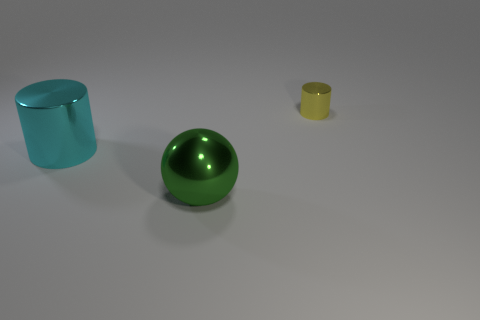Add 3 green metal things. How many objects exist? 6 Subtract all spheres. How many objects are left? 2 Subtract 1 balls. How many balls are left? 0 Subtract all small yellow metal objects. Subtract all tiny purple rubber balls. How many objects are left? 2 Add 3 large metallic cylinders. How many large metallic cylinders are left? 4 Add 2 cyan shiny cylinders. How many cyan shiny cylinders exist? 3 Subtract 0 blue blocks. How many objects are left? 3 Subtract all brown cylinders. Subtract all brown cubes. How many cylinders are left? 2 Subtract all cyan cubes. How many red balls are left? 0 